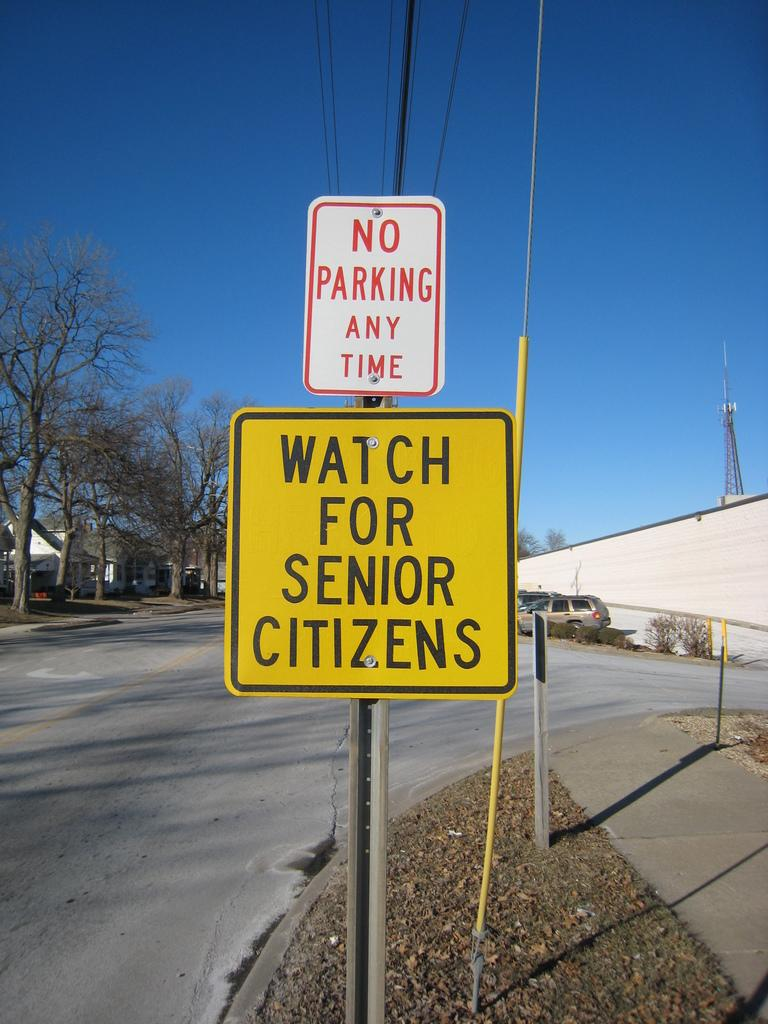<image>
Write a terse but informative summary of the picture. Street signs on the side of the street sating to watch to senior citizens and no parking any time. 